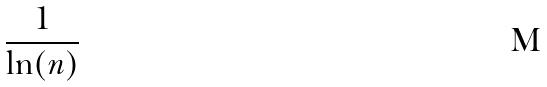<formula> <loc_0><loc_0><loc_500><loc_500>\frac { 1 } { \ln ( n ) }</formula> 